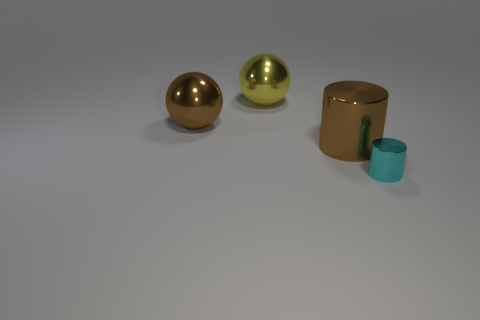What color is the thing right of the cylinder that is to the left of the tiny cyan shiny cylinder?
Your response must be concise. Cyan. How many cylinders are either metal objects or tiny cyan metallic objects?
Offer a terse response. 2. There is a brown shiny object left of the sphere behind the brown metallic ball; how many large brown shiny objects are on the right side of it?
Ensure brevity in your answer.  1. Is there another ball made of the same material as the brown ball?
Your answer should be very brief. Yes. Do the cyan cylinder and the brown cylinder have the same material?
Ensure brevity in your answer.  Yes. There is a large brown object that is to the right of the large yellow shiny object; how many large spheres are in front of it?
Your answer should be very brief. 0. How many purple things are either large shiny cylinders or large metal spheres?
Your answer should be very brief. 0. The tiny thing that is on the right side of the cylinder behind the object that is in front of the big brown metal cylinder is what shape?
Your answer should be compact. Cylinder. The metallic cylinder that is the same size as the brown metal ball is what color?
Offer a terse response. Brown. What number of brown metallic things are the same shape as the big yellow thing?
Provide a succinct answer. 1. 